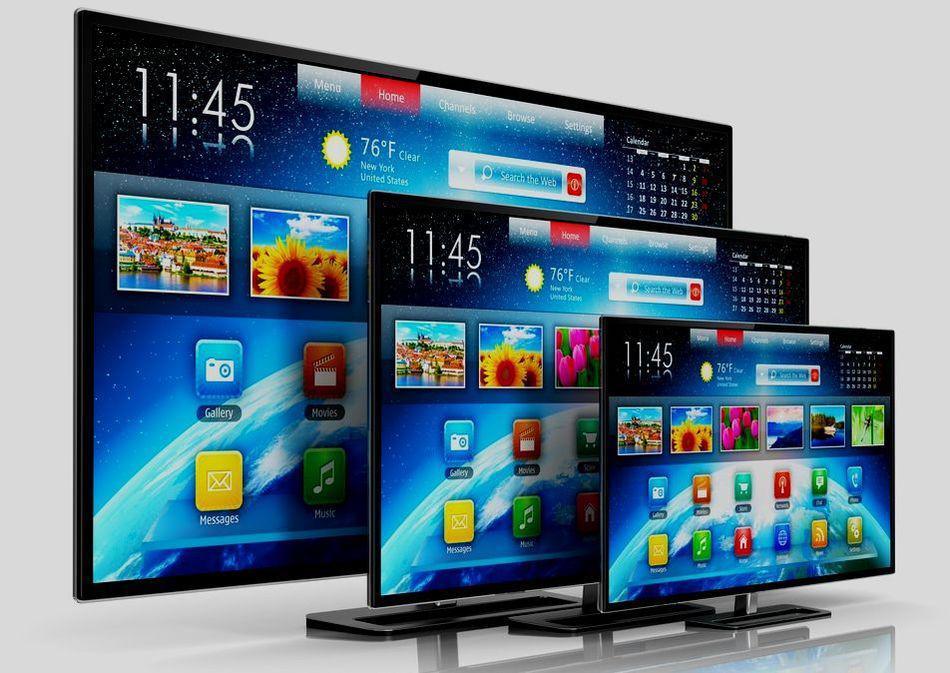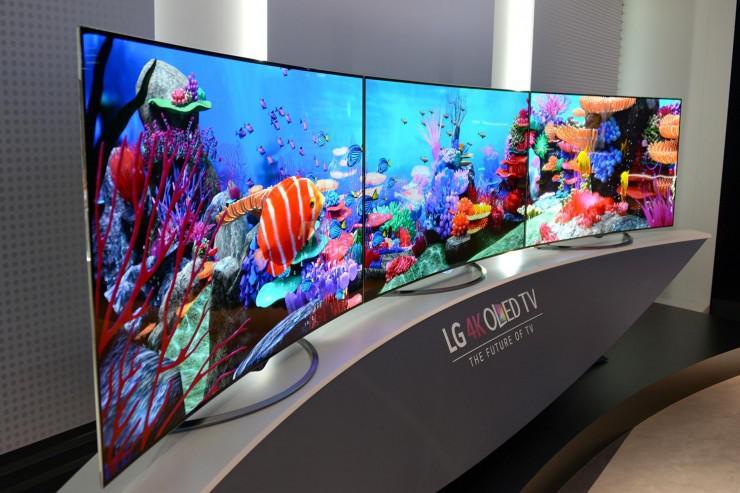The first image is the image on the left, the second image is the image on the right. Considering the images on both sides, is "The right image contains more operating screens than the left image." valid? Answer yes or no. No. The first image is the image on the left, the second image is the image on the right. Given the left and right images, does the statement "There are three monitors increasing in size with identical video being broadcast." hold true? Answer yes or no. Yes. 